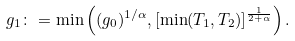Convert formula to latex. <formula><loc_0><loc_0><loc_500><loc_500>g _ { 1 } \colon = \min \left ( ( g _ { 0 } ) ^ { 1 / \alpha } , [ \min ( T _ { 1 } , T _ { 2 } ) ] ^ { \frac { 1 } { 2 + \alpha } } \right ) .</formula> 